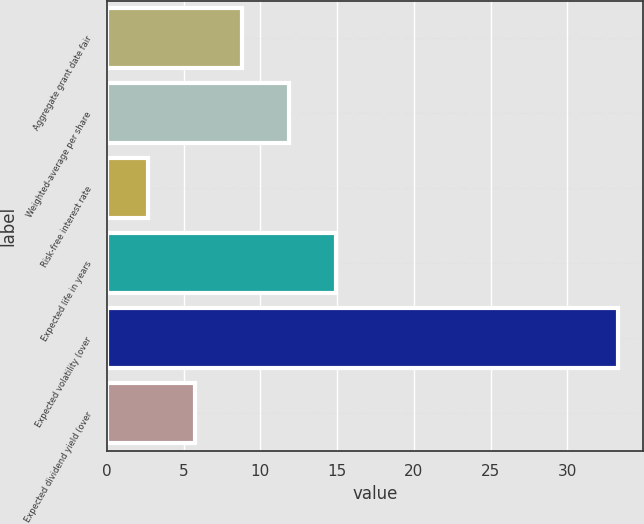Convert chart to OTSL. <chart><loc_0><loc_0><loc_500><loc_500><bar_chart><fcel>Aggregate grant date fair<fcel>Weighted-average per share<fcel>Risk-free interest rate<fcel>Expected life in years<fcel>Expected volatility (over<fcel>Expected dividend yield (over<nl><fcel>8.82<fcel>11.88<fcel>2.7<fcel>14.94<fcel>33.3<fcel>5.76<nl></chart> 